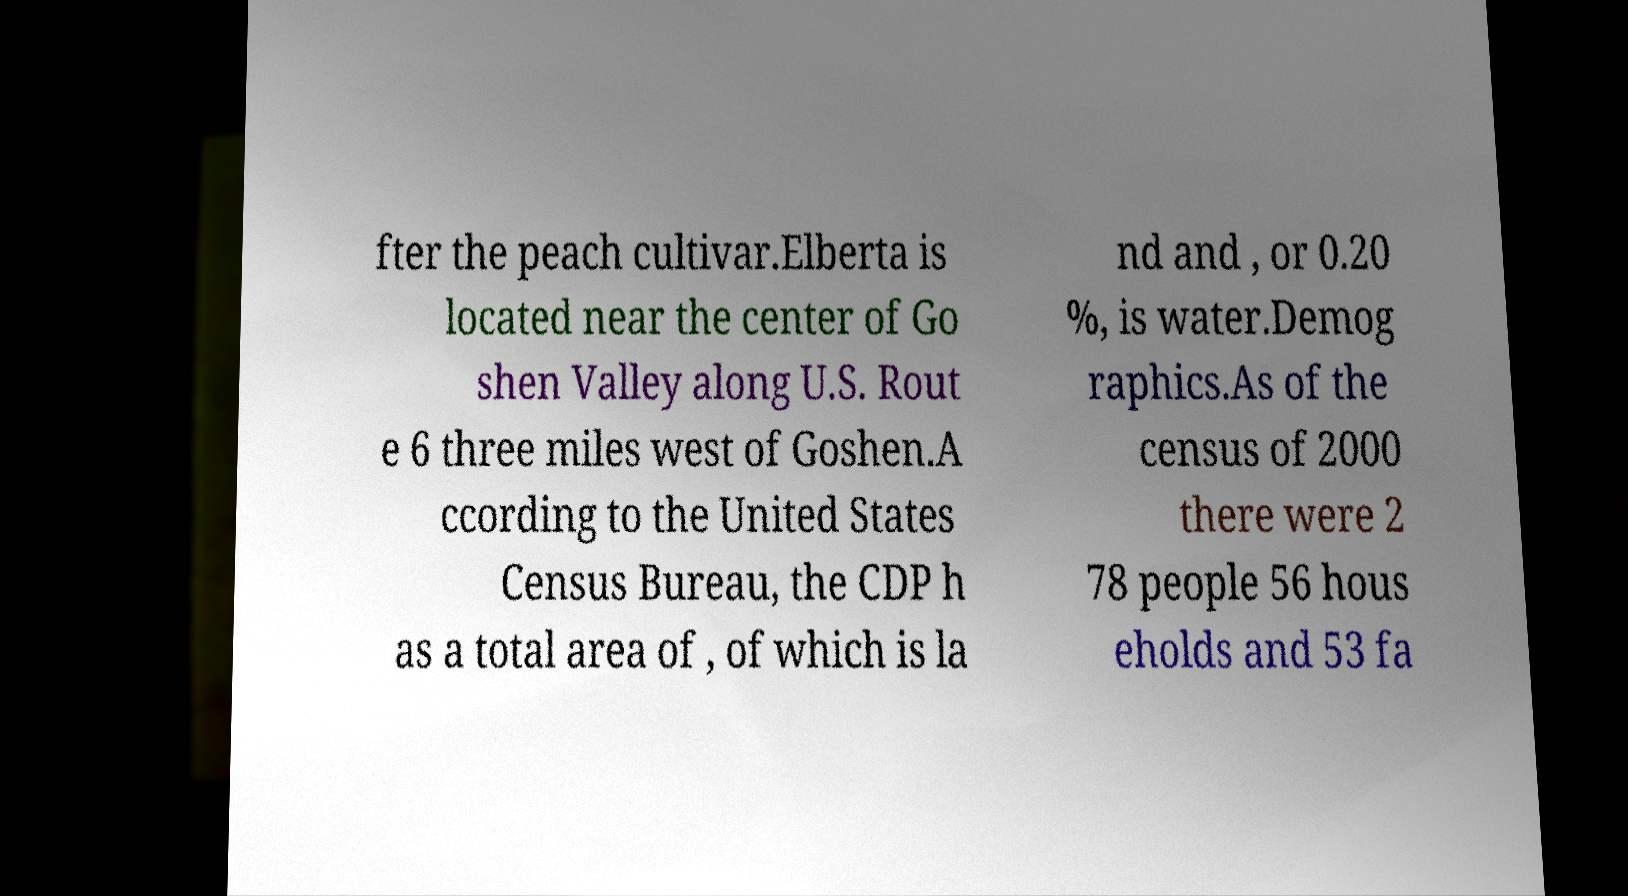Could you extract and type out the text from this image? fter the peach cultivar.Elberta is located near the center of Go shen Valley along U.S. Rout e 6 three miles west of Goshen.A ccording to the United States Census Bureau, the CDP h as a total area of , of which is la nd and , or 0.20 %, is water.Demog raphics.As of the census of 2000 there were 2 78 people 56 hous eholds and 53 fa 